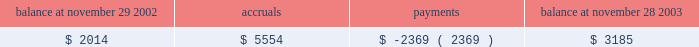Guarantees we adopted fasb interpretation no .
45 ( 201cfin 45 201d ) , 201cguarantor 2019s accounting and disclosure requirements for guarantees , including indirect guarantees of indebtedness of others 201d at the beginning of our fiscal 2003 .
See 201crecent accounting pronouncements 201d for further information regarding fin 45 .
The lease agreements for our three office buildings in san jose , california provide for residual value guarantees .
These lease agreements were in place prior to december 31 , 2002 and are disclosed in note 14 .
In the normal course of business , we provide indemnifications of varying scope to customers against claims of intellectual property infringement made by third parties arising from the use of our products .
Historically , costs related to these indemnification provisions have not been significant and we are unable to estimate the maximum potential impact of these indemnification provisions on our future results of operations .
We have commitments to make certain milestone and/or retention payments typically entered into in conjunction with various acquisitions , for which we have made accruals in our consolidated financial statements .
In connection with our purchases of technology assets during fiscal 2003 , we entered into employee retention agreements totaling $ 2.2 million .
We are required to make payments upon satisfaction of certain conditions in the agreements .
As permitted under delaware law , we have agreements whereby we indemnify our officers and directors for certain events or occurrences while the officer or director is , or was serving , at our request in such capacity .
The indemnification period covers all pertinent events and occurrences during the officer 2019s or director 2019s lifetime .
The maximum potential amount of future payments we could be required to make under these indemnification agreements is unlimited ; however , we have director and officer insurance coverage that limits our exposure and enables us to recover a portion of any future amounts paid .
We believe the estimated fair value of these indemnification agreements in excess of applicable insurance coverage is minimal .
As part of our limited partnership interests in adobe ventures , we have provided a general indemnification to granite ventures , an independent venture capital firm and sole general partner of adobe ventures , for certain events or occurrences while granite ventures is , or was serving , at our request in such capacity provided that granite ventures acts in good faith on behalf of the partnerships .
We are unable to develop an estimate of the maximum potential amount of future payments that could potentially result from any hypothetical future claim , but believe the risk of having to make any payments under this general indemnification to be remote .
We accrue for costs associated with future obligations which include costs for undetected bugs that are discovered only after the product is installed and used by customers .
The accrual remaining at the end of fiscal 2003 primarily relates to new releases of our creative suites products during the fourth quarter of fiscal 2003 .
The table below summarizes the activity related to the accrual during fiscal 2003 : balance at november 29 , 2002 accruals payments balance at november 28 , 2003 .
Advertising expenses we expense all advertising costs as incurred and classify these costs under sales and marketing expense .
Advertising expenses for fiscal years 2003 , 2002 , and 2001 were $ 24.0 million , $ 26.7 million and $ 30.5 million , respectively .
Foreign currency and other hedging instruments statement of financial accounting standards no .
133 ( 201csfas no .
133 201d ) , 201caccounting for derivative instruments and hedging activities , 201d establishes accounting and reporting standards for derivative instruments and hedging activities and requires us to recognize these as either assets or liabilities on the balance sheet and measure them at fair value .
As described in note 15 , gains and losses resulting from .
What is the growth rate in advertising expense in 2002 relative to 2001? 
Computations: ((26.7 - 30.5) / 30.5)
Answer: -0.12459. 